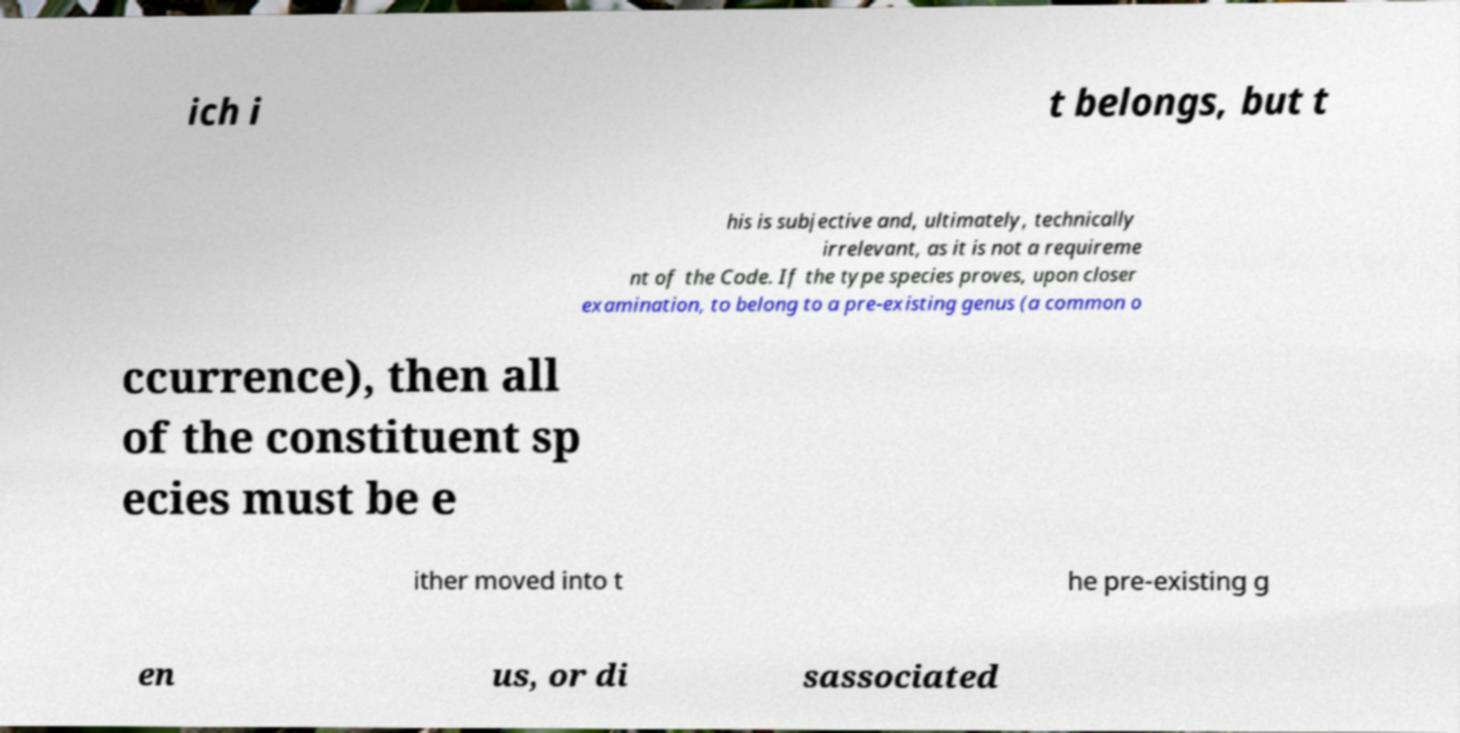What messages or text are displayed in this image? I need them in a readable, typed format. ich i t belongs, but t his is subjective and, ultimately, technically irrelevant, as it is not a requireme nt of the Code. If the type species proves, upon closer examination, to belong to a pre-existing genus (a common o ccurrence), then all of the constituent sp ecies must be e ither moved into t he pre-existing g en us, or di sassociated 